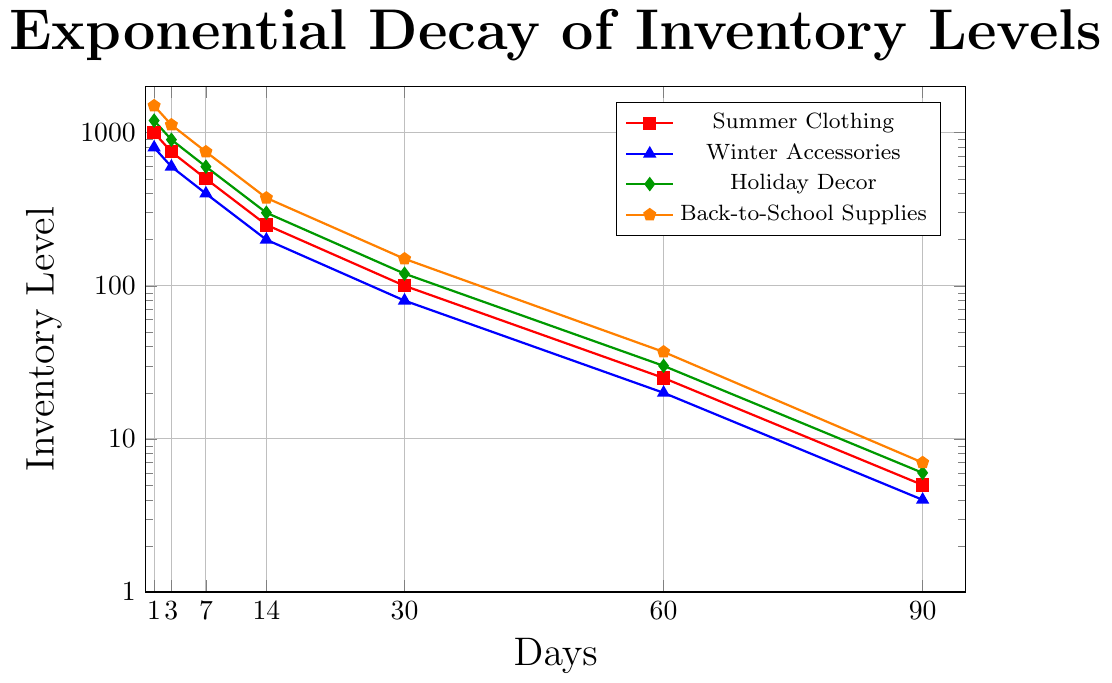Which seasonal category has the fastest inventory decay over 90 days? Observe the inventory decay trend over 90 days for all categories. Back-to-School Supplies decrease from 1500 to 7, the largest decrease among all.
Answer: Back-to-School Supplies Which category shows the highest initial inventory level on day 1? Compare the initial inventory levels (day 1) for all categories. Back-to-School Supplies start with 1500 units, which is the highest.
Answer: Back-to-School Supplies By how much does the inventory of Winter Accessories decrease from day 1 to day 14? Calculate the difference in inventory levels between day 1 and day 14 for Winter Accessories: 800 - 200 = 600 units.
Answer: 600 units Which two categories have their inventory level drop below 50 units first? Identify when each category drops below 50 units by observing the timeline: Summer Clothing (by day 60) and Winter Accessories (by day 60).
Answer: Summer Clothing and Winter Accessories On day 30, which category has the second-highest inventory level? Compare inventory levels for all categories on day 30 and find the second highest: Holiday Decor at 120 units is second to Back-to-School Supplies at 150 units.
Answer: Holiday Decor What is the total inventory level of Summer Clothing and Holiday Decor combined on day 60? Sum the inventory levels of Summer Clothing and Holiday Decor on day 60: 25 (Summer Clothing) + 30 (Holiday Decor) = 55.
Answer: 55 How many days does it take for Back-to-School Supplies’ inventory to decrease below 500? Check when Back-to-School Supplies' inventory falls below 500. This happens between day 7 (750) and day 14 (375), so by day 14.
Answer: 14 days Which category has the steepest decline between day 14 and day 30? Compute the inventory difference between day 14 and day 30 for each category and find the steepest drop. Summer Clothing drops from 250 to 100, so a decline of 150 units.
Answer: Summer Clothing At what day do both Summer Clothing and Winter Accessories inventory levels drop below 10 units? Determine when both categories drop below 10 units. This happens at day 90 for both.
Answer: 90 days 